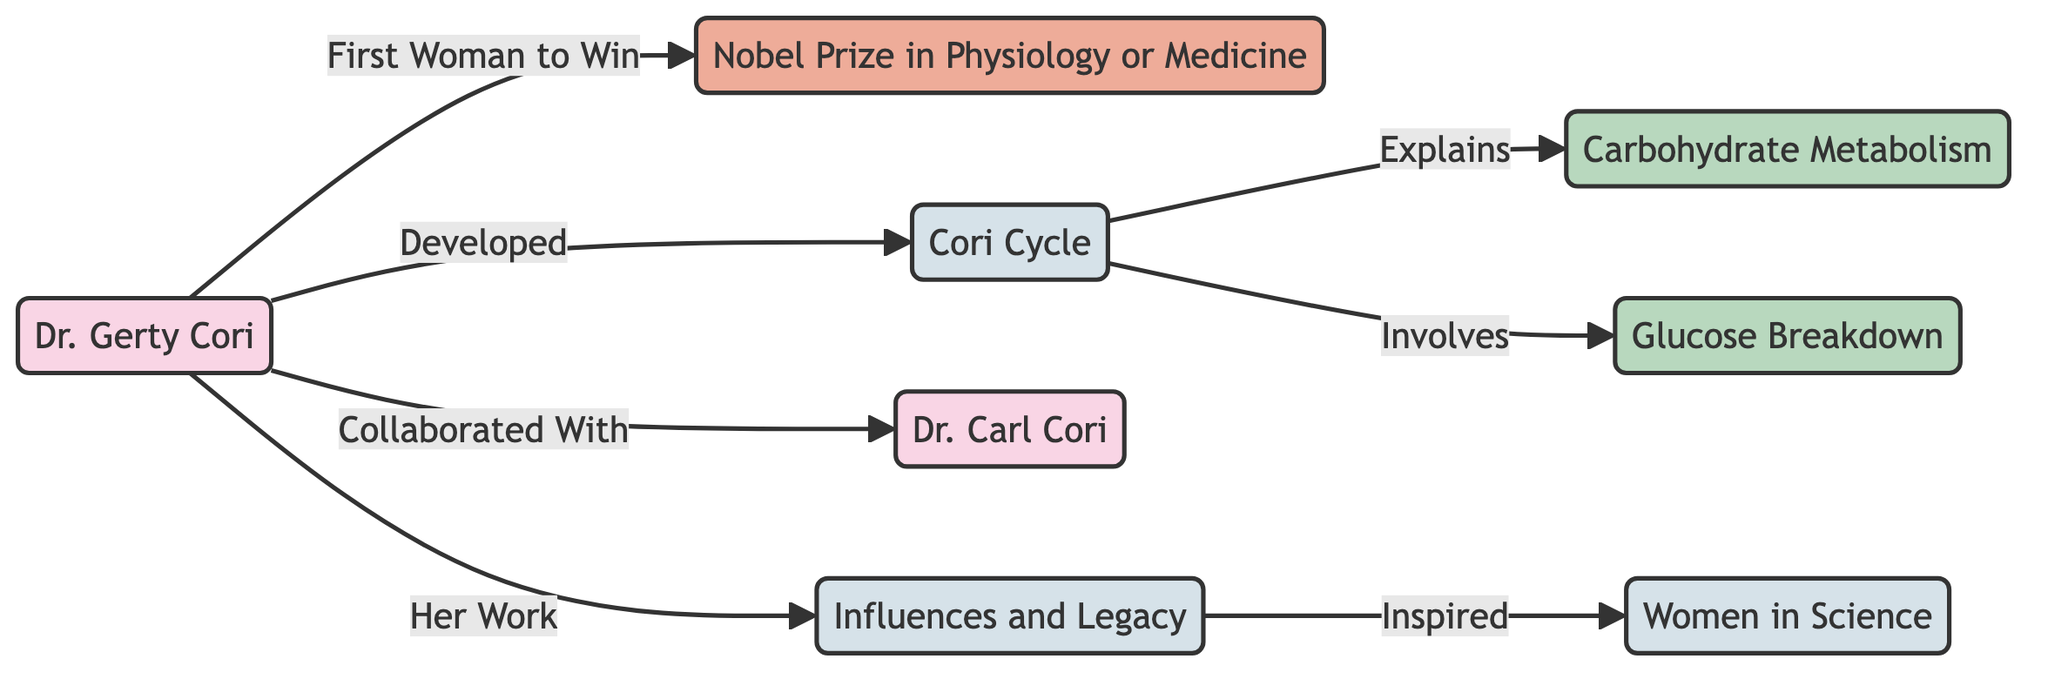What is Dr. Gerty Cori known for? Dr. Gerty Cori is known for being the first woman to win the Nobel Prize in Physiology or Medicine. This information is indicated directly in the diagram as a title associated with her node.
Answer: First Woman to Win What concept did Dr. Gerty Cori develop? The diagram shows that Dr. Gerty Cori developed the "Cori Cycle," which is indicated as a direct relationship stemming from her node.
Answer: Cori Cycle Who collaborated with Dr. Gerty Cori in her research? The diagram points to Dr. Carl Cori as her collaborator, establishing a direct connection between their nodes.
Answer: Dr. Carl Cori What process does the Cori Cycle explain? The diagram identifies that the Cori Cycle explains "Carbohydrate Metabolism," connecting the Cori Cycle node to this process node.
Answer: Carbohydrate Metabolism What does the Cori Cycle involve? According to the diagram, the Cori Cycle involves "Glucose Breakdown," which is explicitly linked to the Cori Cycle node.
Answer: Glucose Breakdown How did Dr. Gerty Cori's work influence future generations? The diagram indicates that her work led to an "Influences and Legacy" node, which connects to "Women in Science," suggesting her inspiration for future female scientists.
Answer: Inspired How many concepts are represented in the diagram? To determine this, we count the nodes categorized as concepts, which include Cori Cycle, Influences and Legacy, and Women in Science. There are three concept nodes in total.
Answer: 3 What are the distinct types of relationships indicated in the diagram? The diagram includes relationships such as "Developed," "Explains," "Involves," "Collaborated With," and "Inspired," showcasing various interactions between nodes.
Answer: 5 What does the "Influences and Legacy" node connect to? The diagram indicates that the "Influences and Legacy" node connects to "Women in Science," reflecting the legacy of Dr. Gerty Cori's contributions.
Answer: Women in Science 